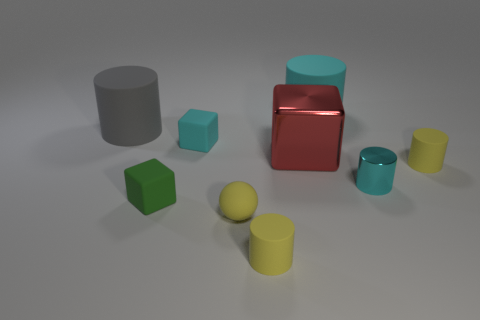Can you describe the color palette used in this image? The color palette of this image contains muted and pastel-like tones, which contribute to a calm and harmonious effect. Prominent colors include dull shades of gray, teal, yellow-green, and variations of red and yellow. These colors are uniformly applied to the objects, enhancing the clean and minimalist aesthetic of the scene. 